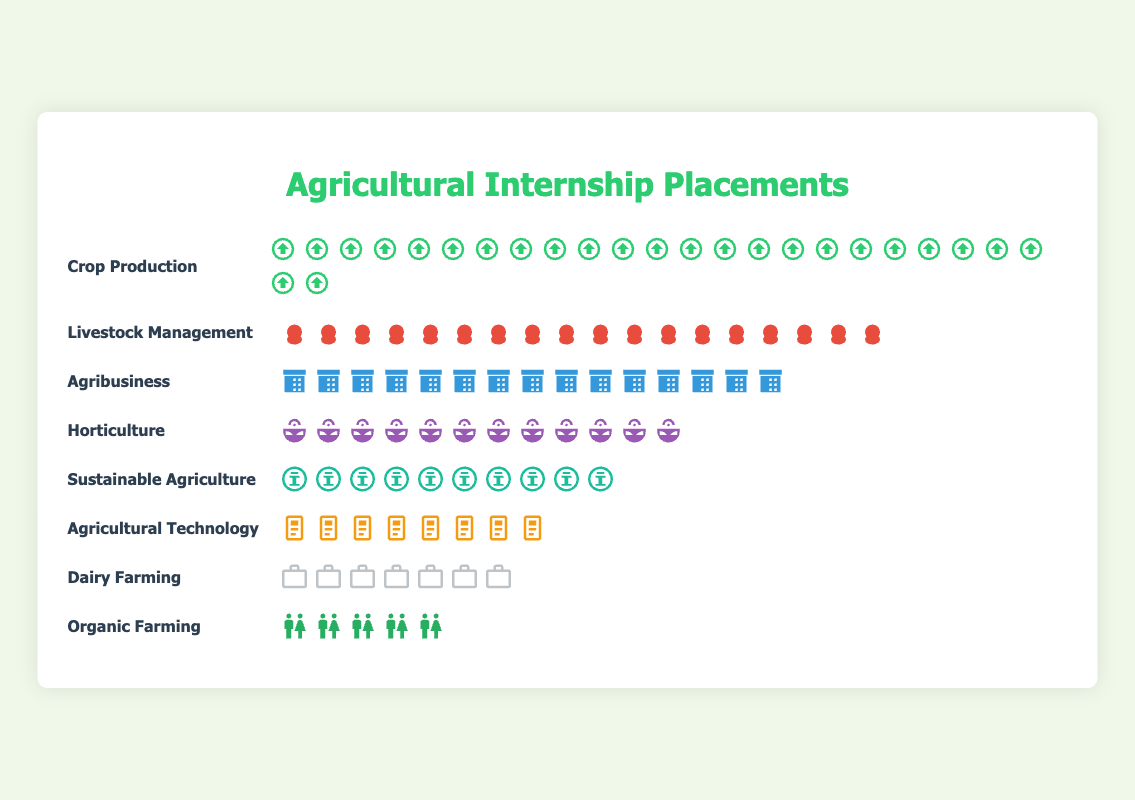What sector has the highest number of student placements? The highest number of student placements can be determined by identifying the sector with the most icons. Crop Production has 25 icons, which is the highest among all sectors.
Answer: Crop Production How many more students are placed in Crop Production compared to Organic Farming? To find the difference, subtract the number of placements in Organic Farming from the number in Crop Production. Crop Production has 25 placements, and Organic Farming has 5 placements, resulting in 25 - 5 = 20 more students in Crop Production.
Answer: 20 What is the total number of student placements across all sectors? Add the number of placements in all sectors: 25 (Crop Production) + 18 (Livestock Management) + 15 (Agribusiness) + 12 (Horticulture) + 10 (Sustainable Agriculture) + 8 (Agricultural Technology) + 7 (Dairy Farming) + 5 (Organic Farming) = 100.
Answer: 100 Which sectors have fewer than 10 student placements? Identify sectors with fewer than 10 icons: Both Agricultural Technology with 8 placements and Dairy Farming with 7 placements have fewer than 10.
Answer: Agricultural Technology and Dairy Farming What is the combined number of student placements in Agribusiness and Horticulture? Add the number of placements in Agribusiness and Horticulture: 15 (Agribusiness) + 12 (Horticulture) = 27.
Answer: 27 Based on the plot, which sector represents the median number of student placements when arranged in ascending order? To find the median, list the sectors in ascending order by student placements: Organic Farming (5), Dairy Farming (7), Agricultural Technology (8), Sustainable Agriculture (10), Horticulture (12), Agribusiness (15), Livestock Management (18), Crop Production (25). The median placement count for eight sectors is the average of the 4th and 5th values, which are 10 and 12. Thus, the median sector is Sustainable Agriculture with 10 placements and Horticulture with 12 placements. For simplicity, pick either.
Answer: Sustainable Agriculture or Horticulture Which sector has exactly half the number of student placements as Livestock Management? Livestock Management has 18 placements. Half of 18 is 9. Check for sectors with 9 placements, but the closest is Agricultural Technology with 8 placements. Thus, no sector exactly halves Livestock Management's placements.
Answer: None What is the least represented sector in terms of student placements? The sector with the fewest icons is the least represented. Organic Farming, with 5 icons, is the least represented sector.
Answer: Organic Farming 